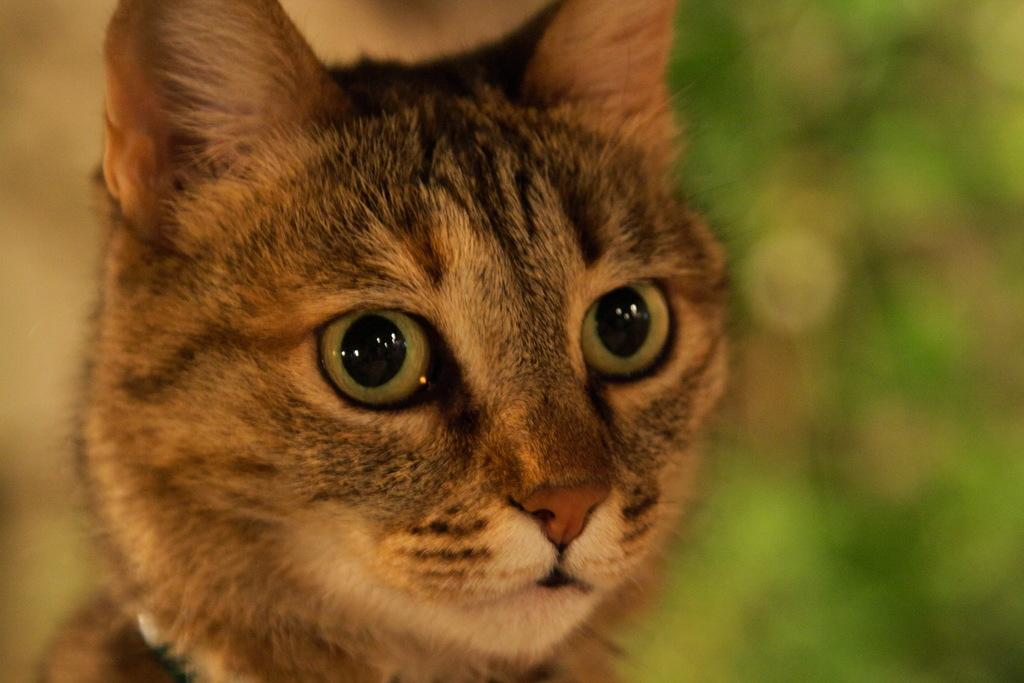What type of animal is in the image? There is a brown color cat in the image. What is the cat doing in the image? The cat is looking into the camera. Can you describe the background of the image? The background of the image is blurred. What type of desk is visible in the image? There is no desk present in the image; it features a brown color cat looking into the camera with a blurred background. 